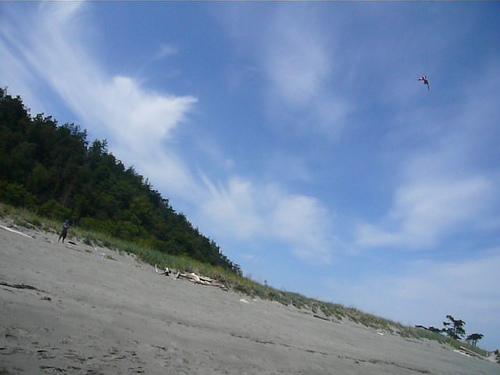Who is holding the camera?
Be succinct. Man. What color is the snow?
Write a very short answer. No snow. How is the weather?
Give a very brief answer. Sunny. What is in the background?
Concise answer only. Trees. Where is the person located?
Be succinct. Beach. Is the bird in the Foreground or Background?
Quick response, please. Background. How many rocks are shown?
Write a very short answer. 0. Can you see any grass?
Quick response, please. Yes. Is this a warm summer day?
Answer briefly. Yes. Is there snow on the ground?
Answer briefly. No. Is this landscape epic?
Keep it brief. No. Is it snowing?
Keep it brief. No. What object is in the sky?
Keep it brief. Kite. What time of year is it?
Quick response, please. Summer. How much snow is on the ground?
Write a very short answer. 0. Is this in New Zealand?
Short answer required. Yes. Can you see the sky?
Concise answer only. Yes. 